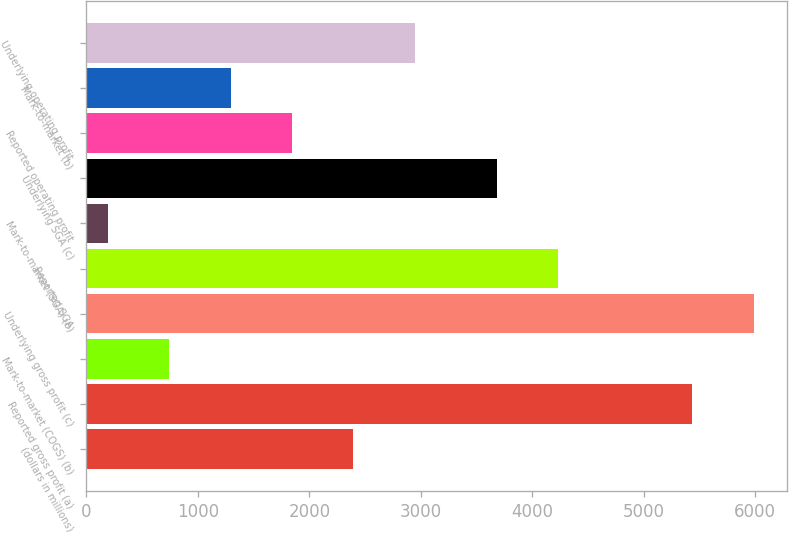Convert chart. <chart><loc_0><loc_0><loc_500><loc_500><bar_chart><fcel>(dollars in millions)<fcel>Reported gross profit (a)<fcel>Mark-to-market (COGS) (b)<fcel>Underlying gross profit (c)<fcel>Reported SGA<fcel>Mark-to-market (SGA) (b)<fcel>Underlying SGA (c)<fcel>Reported operating profit<fcel>Mark-to-market (b)<fcel>Underlying operating profit<nl><fcel>2393<fcel>5434<fcel>743<fcel>5984<fcel>4229<fcel>193<fcel>3679<fcel>1843<fcel>1293<fcel>2943<nl></chart> 